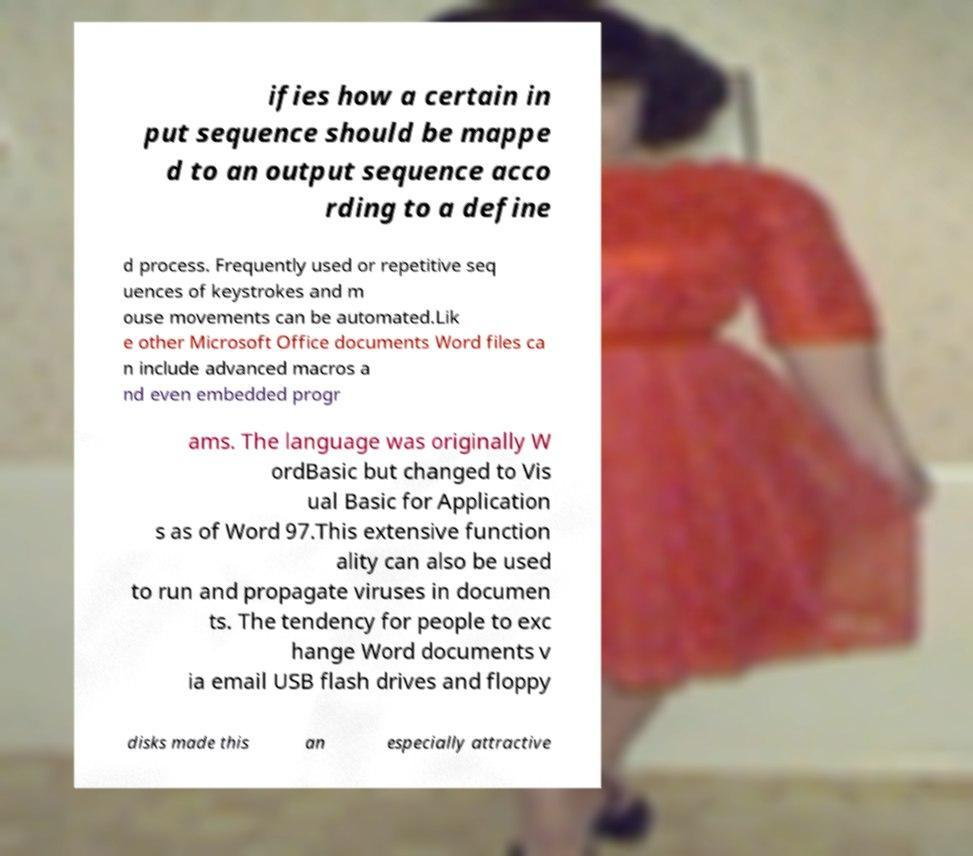I need the written content from this picture converted into text. Can you do that? ifies how a certain in put sequence should be mappe d to an output sequence acco rding to a define d process. Frequently used or repetitive seq uences of keystrokes and m ouse movements can be automated.Lik e other Microsoft Office documents Word files ca n include advanced macros a nd even embedded progr ams. The language was originally W ordBasic but changed to Vis ual Basic for Application s as of Word 97.This extensive function ality can also be used to run and propagate viruses in documen ts. The tendency for people to exc hange Word documents v ia email USB flash drives and floppy disks made this an especially attractive 